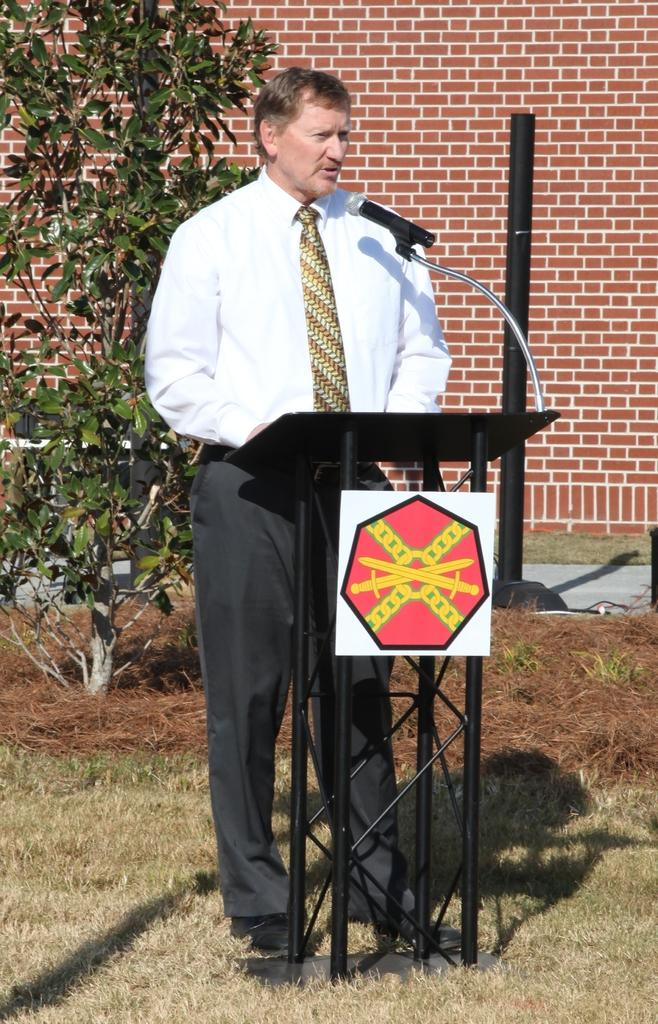What type of vegetation can be seen in the image? There is grass in the image. What structure is present on the podium in the image? There is a board on the podium in the image. What object can be seen standing upright in the image? There is a pole in the image. What type of plant is visible in the image? There is a tree in the image. What type of path is visible in the image? There is a path in the image. What is the man wearing in the image? The man is wearing a tie in the image. Where is the man standing in the image? The man is standing on the ground in the image. What can be seen in the background of the image? There is a wall visible in the background of the image. How many chickens are visible on the podium in the image? There are no chickens present on the podium or anywhere else in the image. What type of curve can be seen in the image? There is no curve visible in the image. 